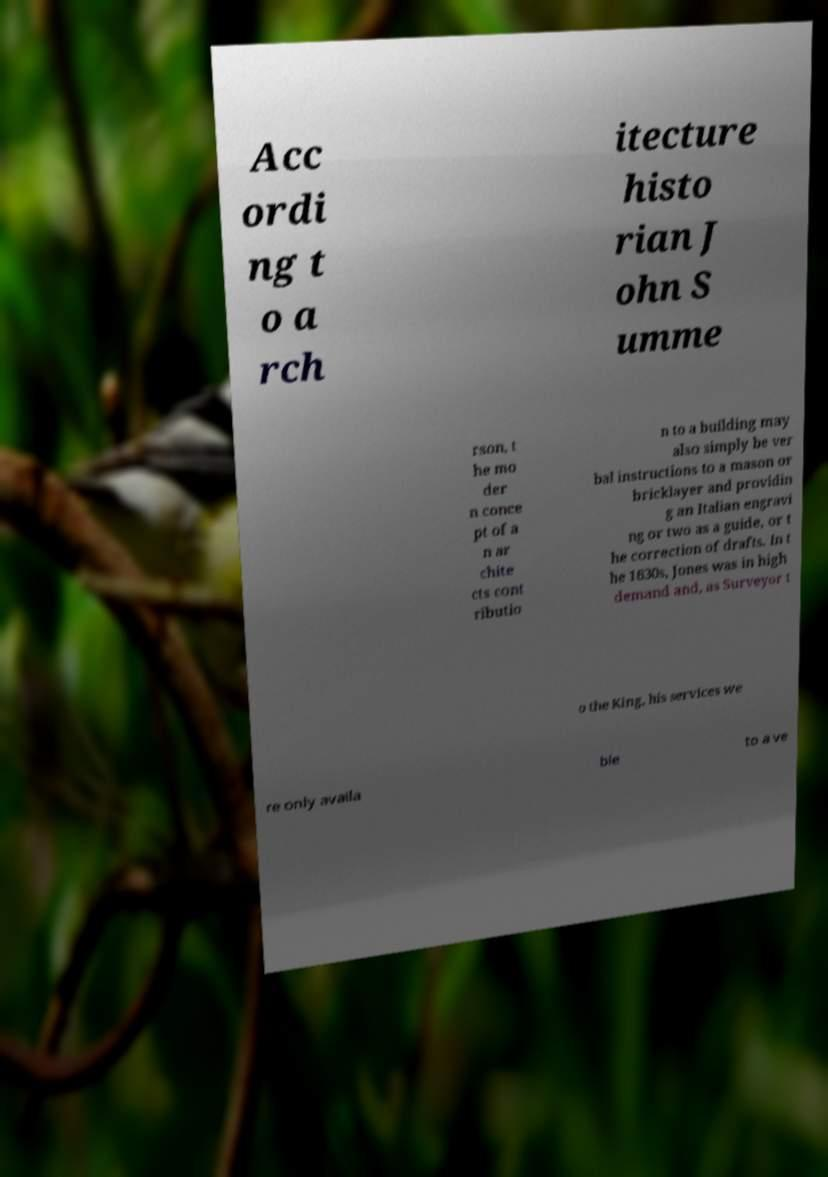Please read and relay the text visible in this image. What does it say? Acc ordi ng t o a rch itecture histo rian J ohn S umme rson, t he mo der n conce pt of a n ar chite cts cont ributio n to a building may also simply be ver bal instructions to a mason or bricklayer and providin g an Italian engravi ng or two as a guide, or t he correction of drafts. In t he 1630s, Jones was in high demand and, as Surveyor t o the King, his services we re only availa ble to a ve 